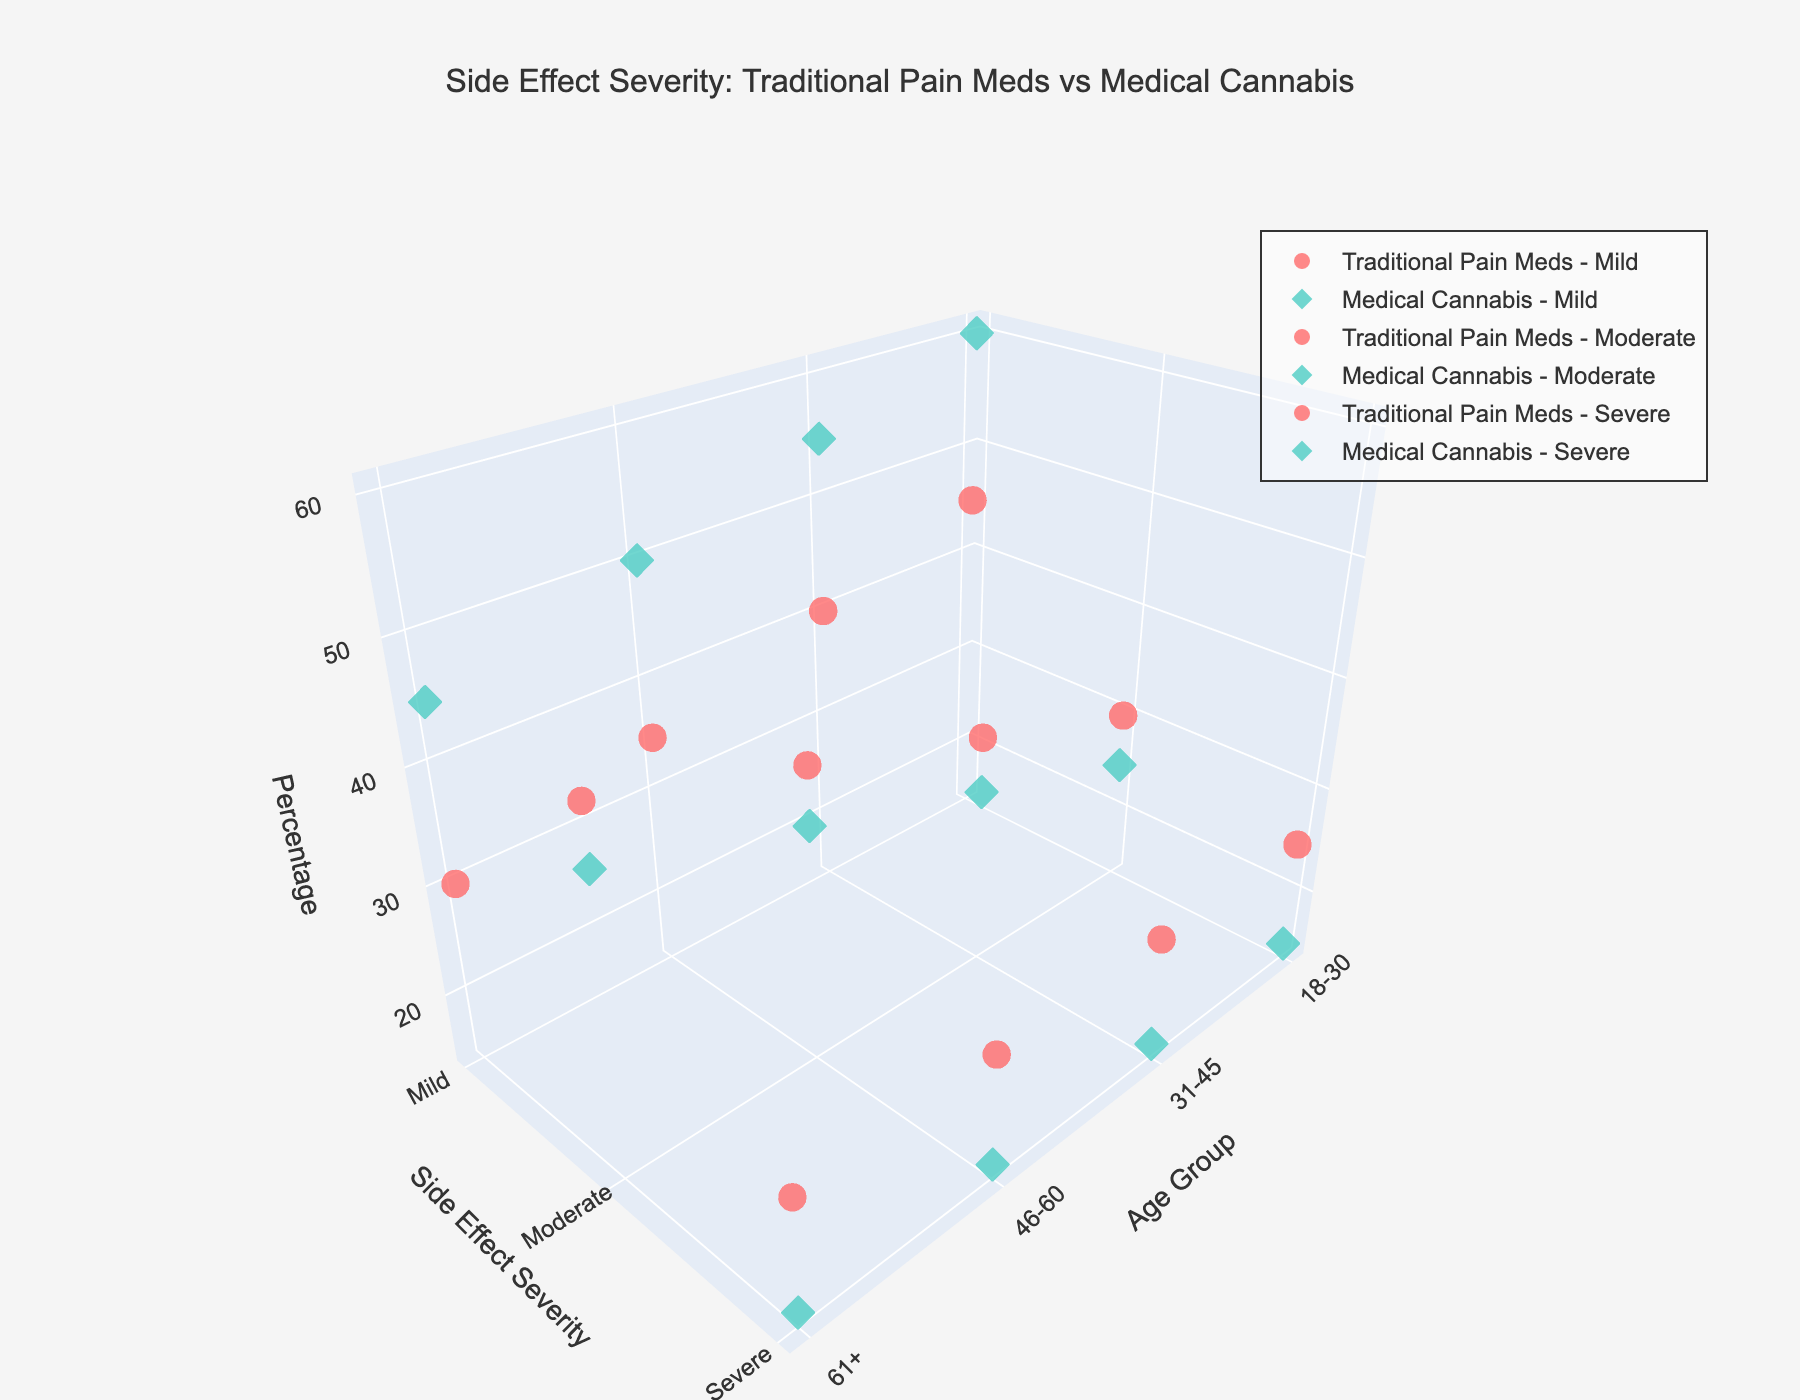What's the title of the figure? The title of the figure is prominently displayed at the top, indicating "Side Effect Severity: Traditional Pain Meds vs Medical Cannabis."
Answer: Side Effect Severity: Traditional Pain Meds vs Medical Cannabis What are the axes labels? The 3D plot has three axes: the x-axis labeled "Age Group," the y-axis labeled "Side Effect Severity," and the z-axis labeled "Percentage."
Answer: Age Group, Side Effect Severity, Percentage In the age group 18-30, which medication has a higher percentage of mild side effects? For the age group 18-30, the percentage of mild side effects for Traditional Pain Meds is 45, while for Medical Cannabis it is 60.
Answer: Medical Cannabis How many side effect severity levels are shown? The figure shows three side effect severity levels: "Mild," "Moderate," and "Severe."
Answer: Three Which age group shows the highest percentage of moderate side effects from traditional pain meds? In the 61+ age group, traditional pain meds show the highest percentage of moderate side effects, which is 45.
Answer: 61+ Compare the severe side effects of traditional pain medications and medical cannabis in the 31-45 age group. In the 31-45 age group, traditional pain medications have a severe side effect percentage of 25, while medical cannabis shows a percentage of 15.
Answer: Traditional Pain Meds have a higher percentage What is the trend in mild side effects for traditional pain meds across different age groups? The mild side effects percentages for traditional pain meds decrease with each succeeding age group: 18-30 (45), 31-45 (40), 46-60 (35), 61+ (30).
Answer: Decreasing In which age group is the percentage difference of severe side effects between traditional pain meds and medical cannabis the largest? The percentage difference of severe side effects between traditional pain meds and medical cannabis is the same for each age group, i.e., 10.
Answer: Equal Overall, which medication has fewer severe side effects across all age groups? Medical Cannabis has a lower percentage of severe side effects across all age groups compared to Traditional Pain Meds.
Answer: Medical Cannabis What is the color scheme used to differentiate between the medications? Traditional Pain Meds are represented by a reddish color, while Medical Cannabis is represented by a greenish color.
Answer: Reddish and greenish 